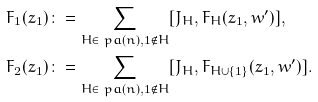Convert formula to latex. <formula><loc_0><loc_0><loc_500><loc_500>F _ { 1 } ( z _ { 1 } ) & \colon = \sum _ { H \in \ p a ( n ) , 1 \not \in H } [ J _ { H } , F _ { H } ( z _ { 1 } , w ^ { \prime } ) ] , \\ F _ { 2 } ( z _ { 1 } ) & \colon = \sum _ { H \in \ p a ( n ) , 1 \not \in H } [ J _ { H } , F _ { H \cup \{ 1 \} } ( z _ { 1 } , w ^ { \prime } ) ] .</formula> 